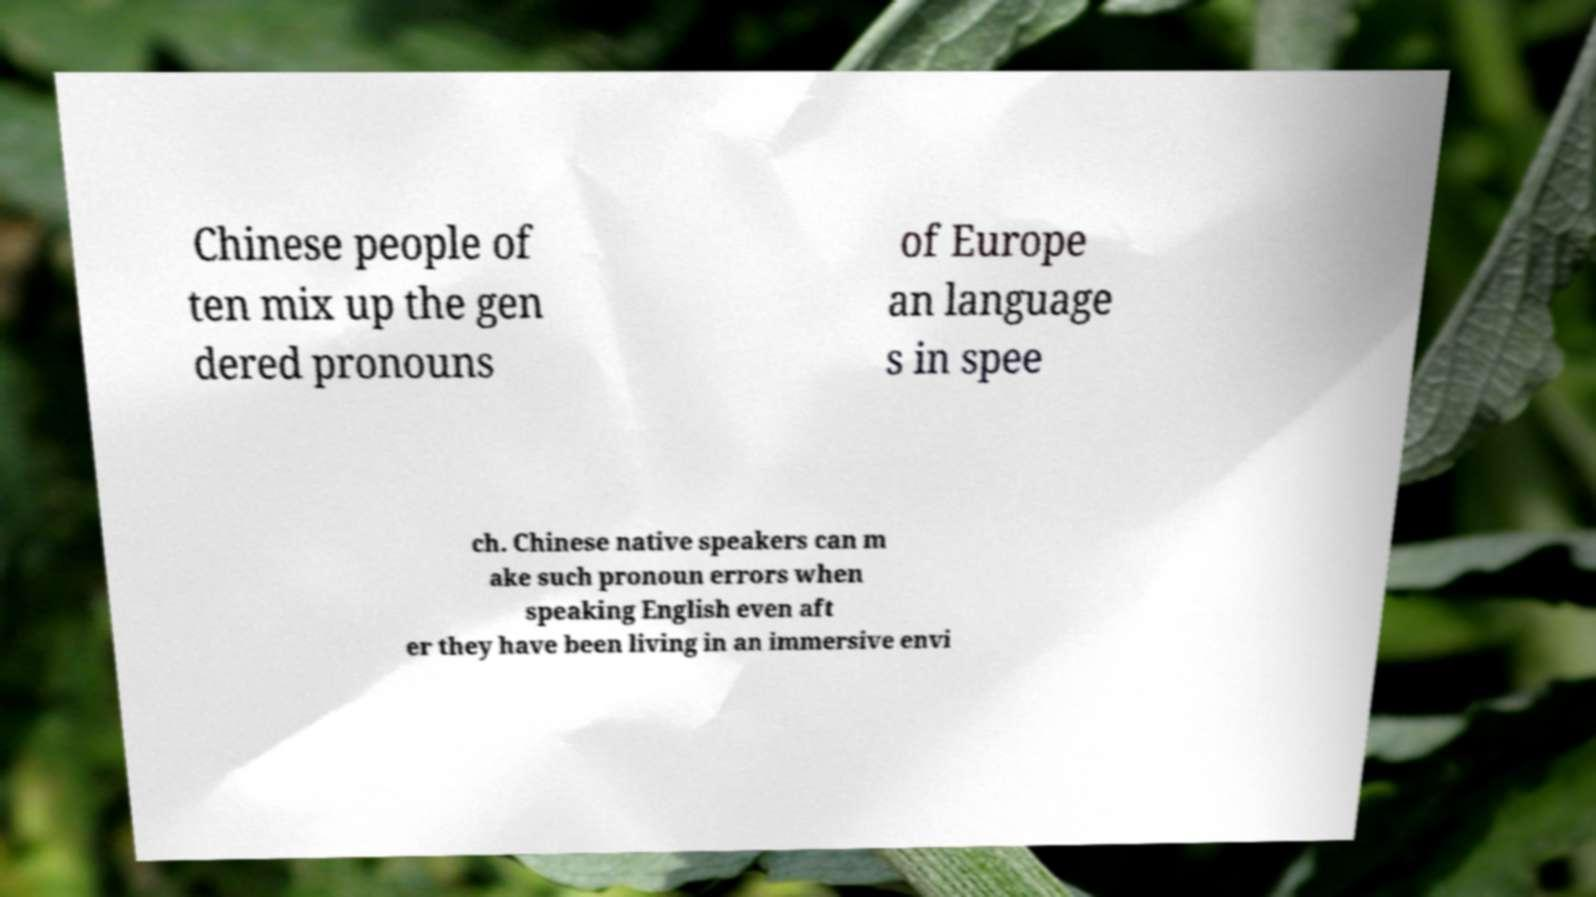Could you extract and type out the text from this image? Chinese people of ten mix up the gen dered pronouns of Europe an language s in spee ch. Chinese native speakers can m ake such pronoun errors when speaking English even aft er they have been living in an immersive envi 